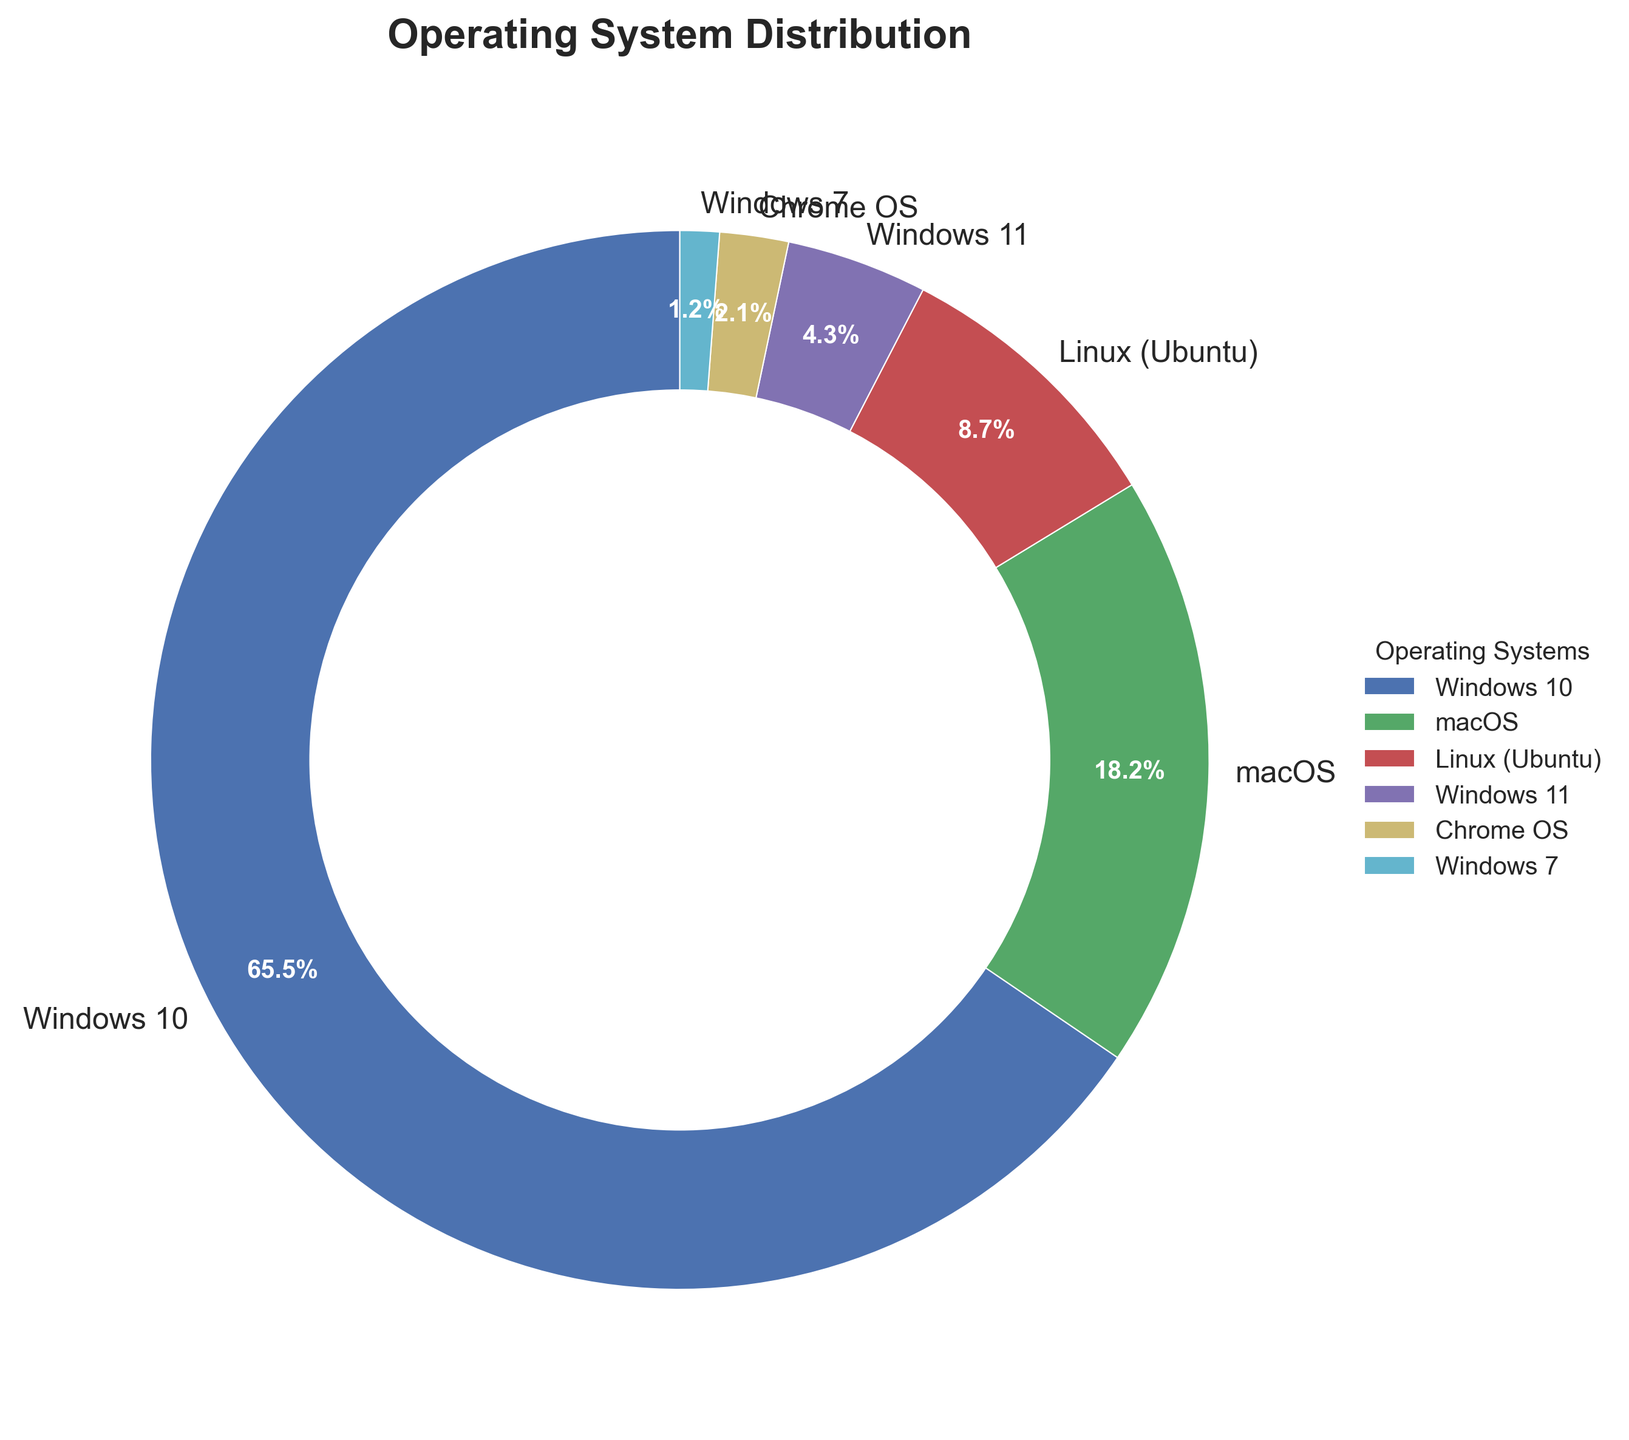What percentage of employees use a version of Windows (Windows 10, Windows 11, or Windows 7)? First, sum the percentages of Windows 10, Windows 11, and Windows 7: 65.5 + 4.3 + 1.2 = 71.0.
Answer: 71.0 Which operating system has the second highest usage? The operating systems and their percentages are: Windows 10 (65.5), macOS (18.2), Linux (Ubuntu) (8.7), Windows 11 (4.3), Chrome OS (2.1), Windows 7 (1.2). The second highest is macOS with 18.2%.
Answer: macOS What is the combined percentage of employees using macOS and Linux (Ubuntu)? Add the percentages of macOS and Linux (Ubuntu): 18.2 + 8.7 = 26.9.
Answer: 26.9 How much higher is the proportion of employees using Windows 10 compared to Linux (Ubuntu)? Subtract the percentage of Linux (Ubuntu) users from Windows 10 users: 65.5 - 8.7 = 56.8.
Answer: 56.8 Which operating system is represented by the light green color in the chart? By observing the chart and identifying color associations: light green represents macOS.
Answer: macOS Is the percentage of employees using Windows 11 higher or lower than those using Chrome OS? By comparing the percentages, Windows 11 (4.3%) vs Chrome OS (2.1%), Windows 11 has a higher percentage.
Answer: Higher What is the approximate difference in usage between the operating system with the highest usage and the one with the lowest usage? Find the difference between the highest (Windows 10 at 65.5%) and the lowest (Windows 7 at 1.2%): 65.5 - 1.2 = 64.3.
Answer: 64.3 Do Chrome OS and Windows 7 combined surpass the usage of Linux (Ubuntu)? Add the percentages of Chrome OS and Windows 7: 2.1 + 1.2 = 3.3. Compare 3.3 with Linux (Ubuntu) at 8.7%; they do not surpass.
Answer: No 